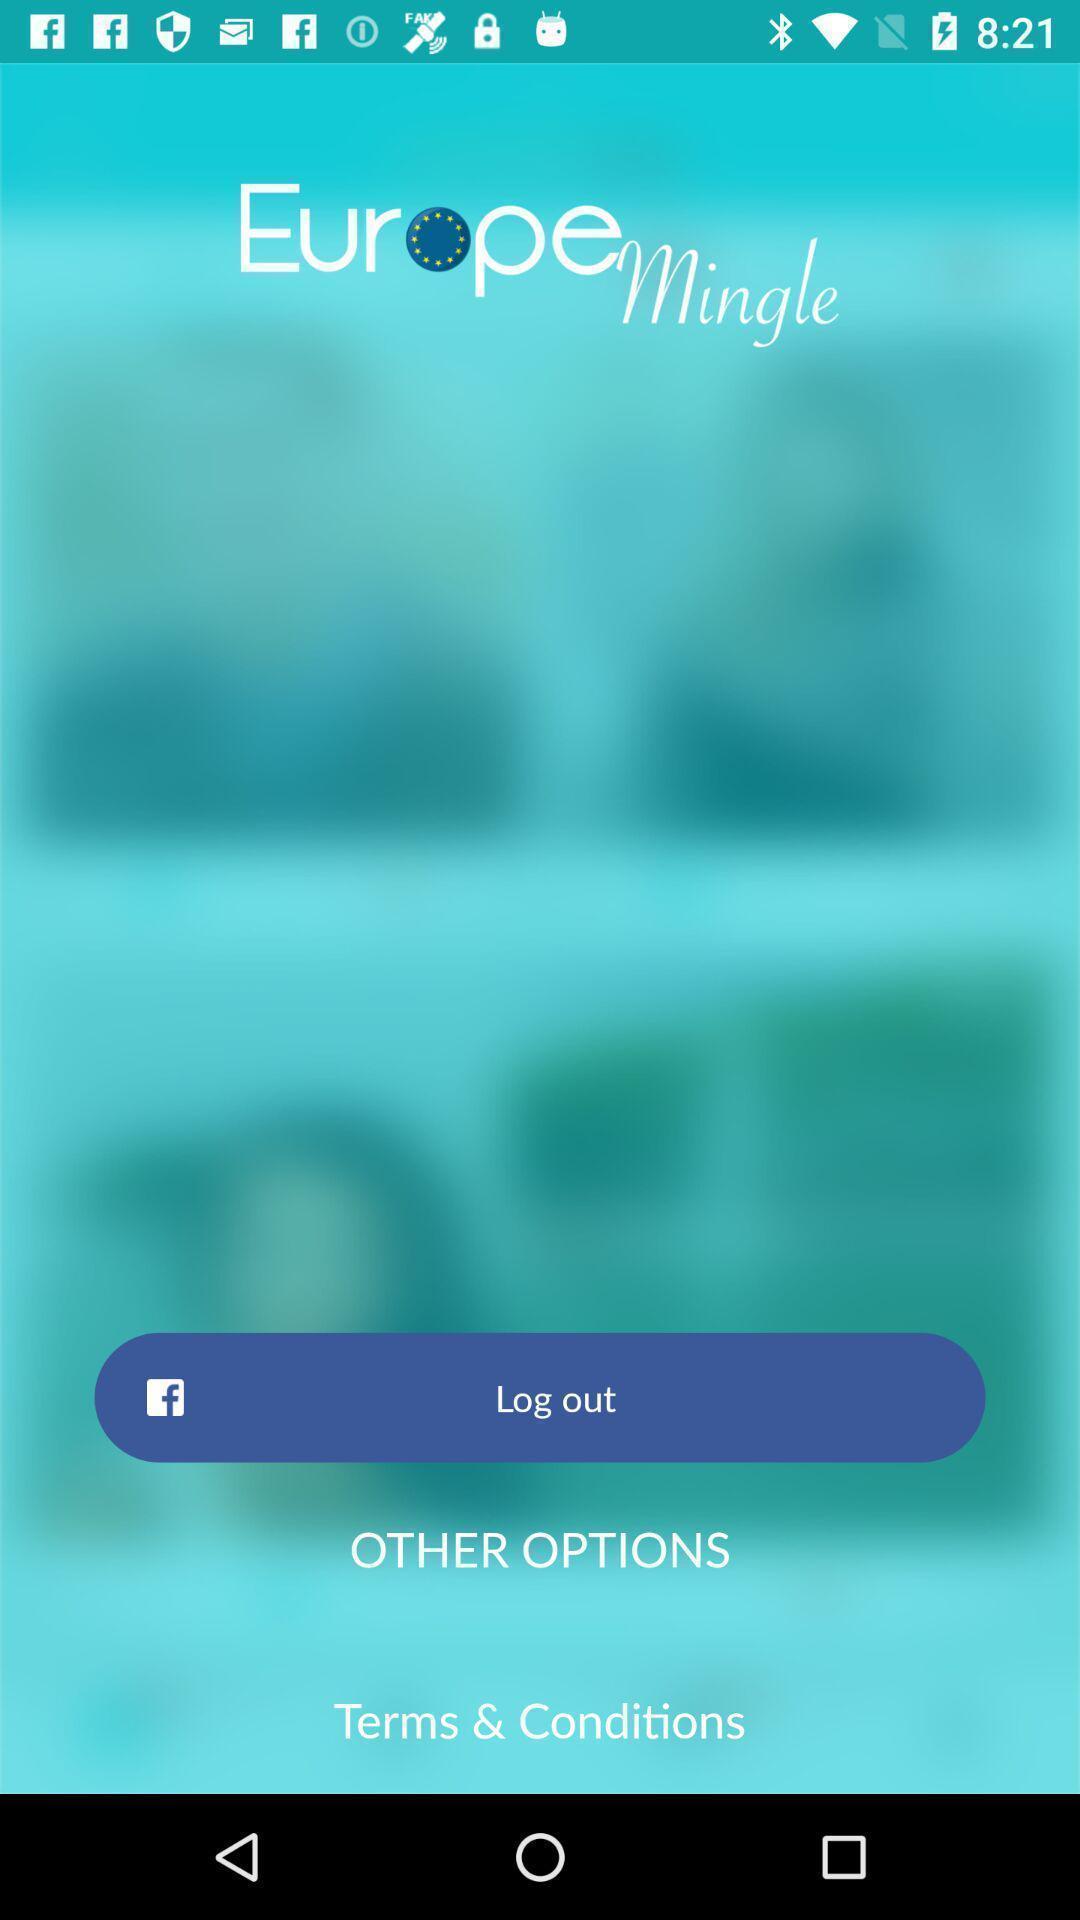Explain what's happening in this screen capture. Welcome page of social application. 